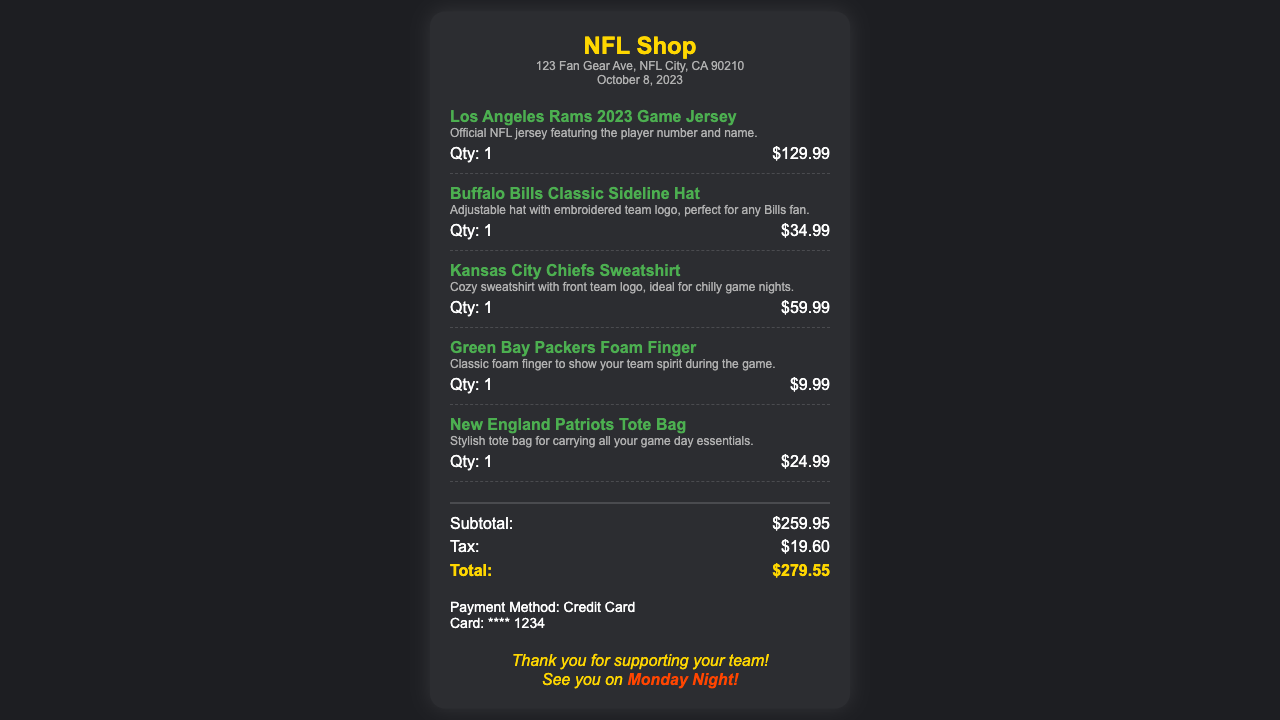What is the purchase date? The purchase date is mentioned in the document under the purchase date section.
Answer: October 8, 2023 What item has the highest price? The item details show the prices of each item, and the highest price is for the jersey.
Answer: Los Angeles Rams 2023 Game Jersey How much was paid for the New England Patriots Tote Bag? The document lists the price for each item, and the tote bag's price is indicated.
Answer: $24.99 What is the subtotal amount? The subtotal is summarized in the totals section of the document.
Answer: $259.95 How much was charged in tax? The tax amount is also displayed in the totals section of the document.
Answer: $19.60 What is the total amount spent? The total amount is the sum of the subtotal and tax, as shown in the totals section.
Answer: $279.55 What payment method was used? The payment information section specifies the payment method used for the purchase.
Answer: Credit Card What type of item is the Green Bay Packers item? The document describes the item associated with the Green Bay Packers.
Answer: Foam Finger How many items were purchased? The number of items can be determined by counting the individual item entries in the document.
Answer: 5 